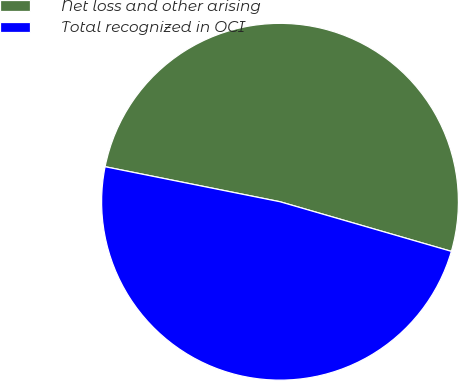Convert chart. <chart><loc_0><loc_0><loc_500><loc_500><pie_chart><fcel>Net loss and other arising<fcel>Total recognized in OCI<nl><fcel>51.34%<fcel>48.66%<nl></chart> 